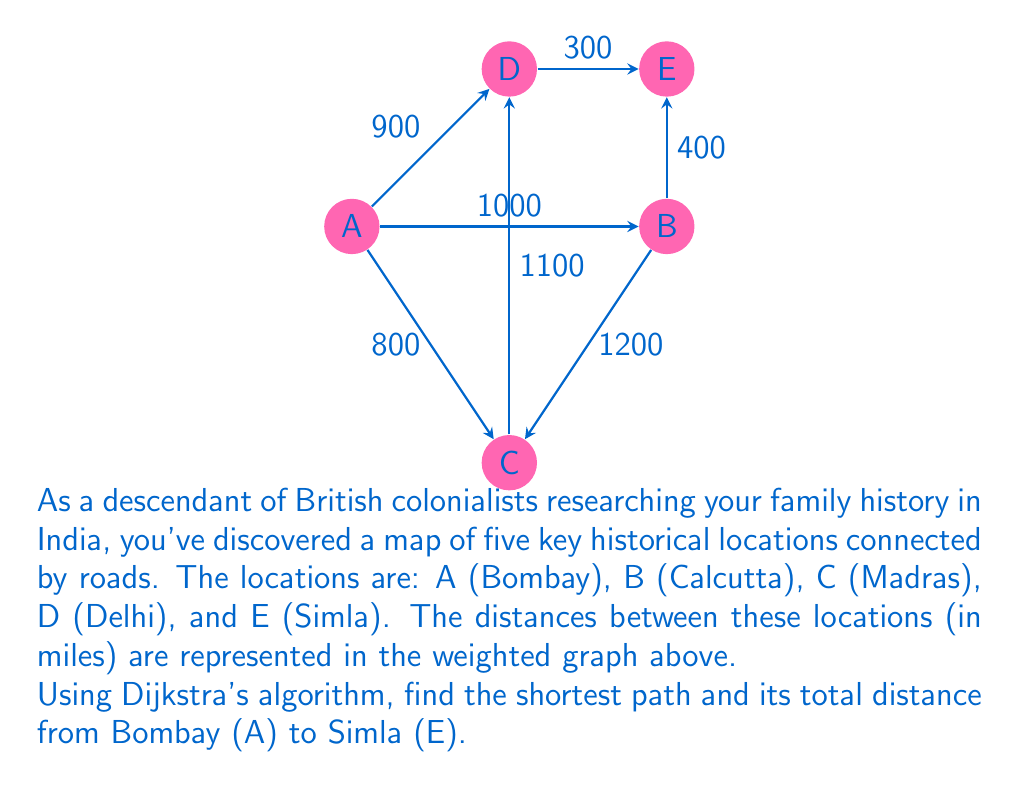Provide a solution to this math problem. Let's apply Dijkstra's algorithm to find the shortest path from A (Bombay) to E (Simla):

1) Initialize:
   - Distance to A: 0
   - Distance to all other vertices: $\infty$
   - Set of unvisited nodes: {A, B, C, D, E}

2) Start from A:
   - Update distances: A(0), B(1000), C(800), D(900), E($\infty$)
   - Mark A as visited
   - Unvisited set: {B, C, D, E}

3) Choose the closest unvisited node: C
   - Update distances through C: No changes
   - Mark C as visited
   - Unvisited set: {B, D, E}

4) Choose the closest unvisited node: D
   - Update distances through D:
     E: min($\infty$, 900 + 300) = 1200
   - Mark D as visited
   - Unvisited set: {B, E}

5) Choose the closest unvisited node: B
   - Update distances through B:
     E: min(1200, 1000 + 400) = 1200
   - Mark B as visited
   - Unvisited set: {E}

6) Visit E (only remaining node)

The shortest path is A -> D -> E with a total distance of 1200 miles.

Path: A (Bombay) -> D (Delhi) -> E (Simla)
Distance: 900 + 300 = 1200 miles
Answer: A -> D -> E, 1200 miles 